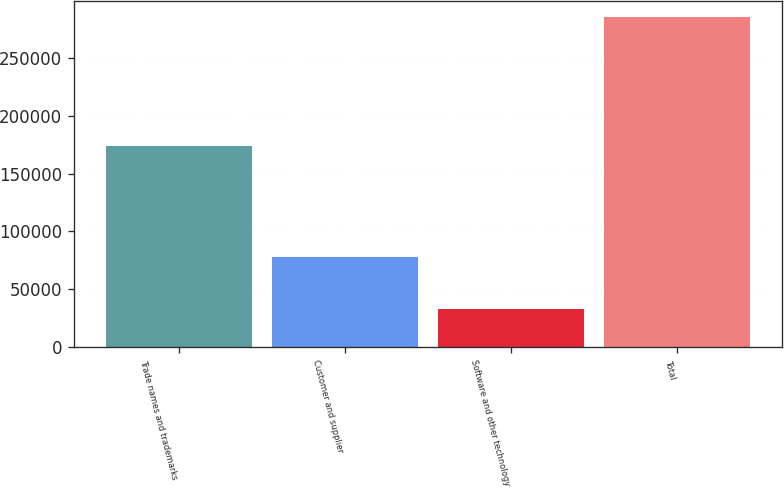<chart> <loc_0><loc_0><loc_500><loc_500><bar_chart><fcel>Trade names and trademarks<fcel>Customer and supplier<fcel>Software and other technology<fcel>Total<nl><fcel>173946<fcel>77980<fcel>33329<fcel>285255<nl></chart> 